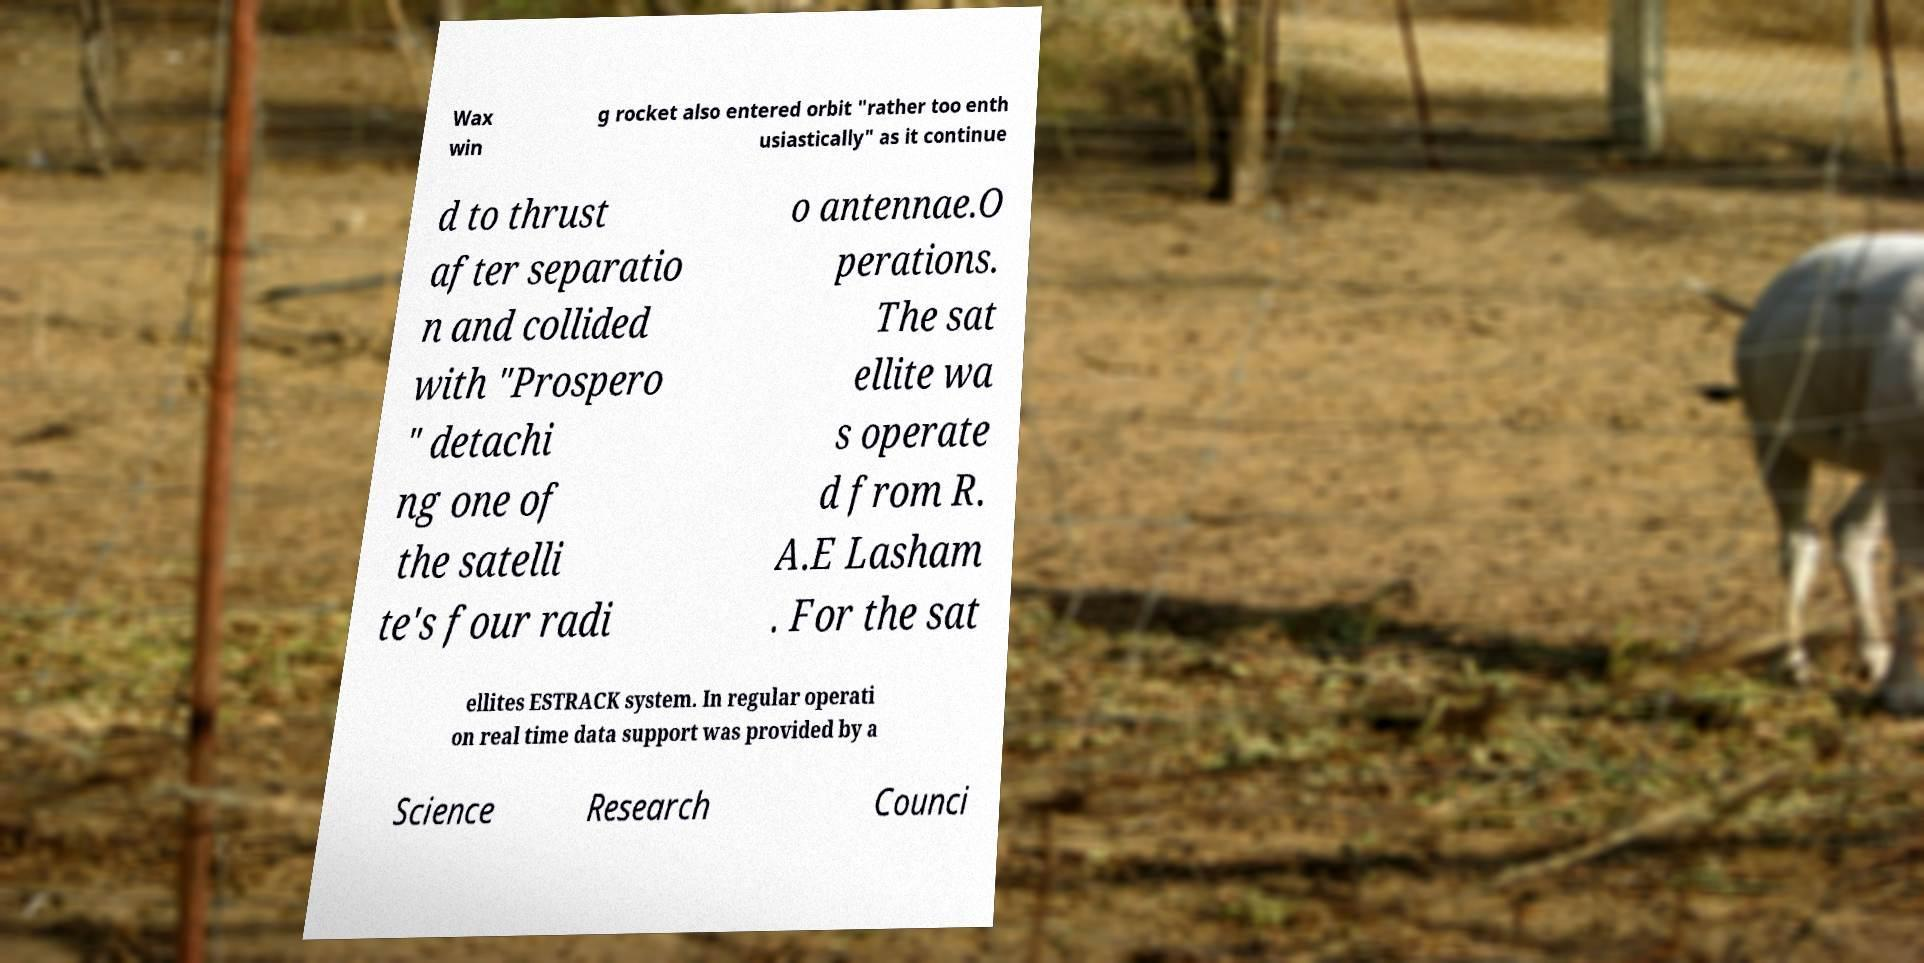Could you assist in decoding the text presented in this image and type it out clearly? Wax win g rocket also entered orbit "rather too enth usiastically" as it continue d to thrust after separatio n and collided with "Prospero " detachi ng one of the satelli te's four radi o antennae.O perations. The sat ellite wa s operate d from R. A.E Lasham . For the sat ellites ESTRACK system. In regular operati on real time data support was provided by a Science Research Counci 